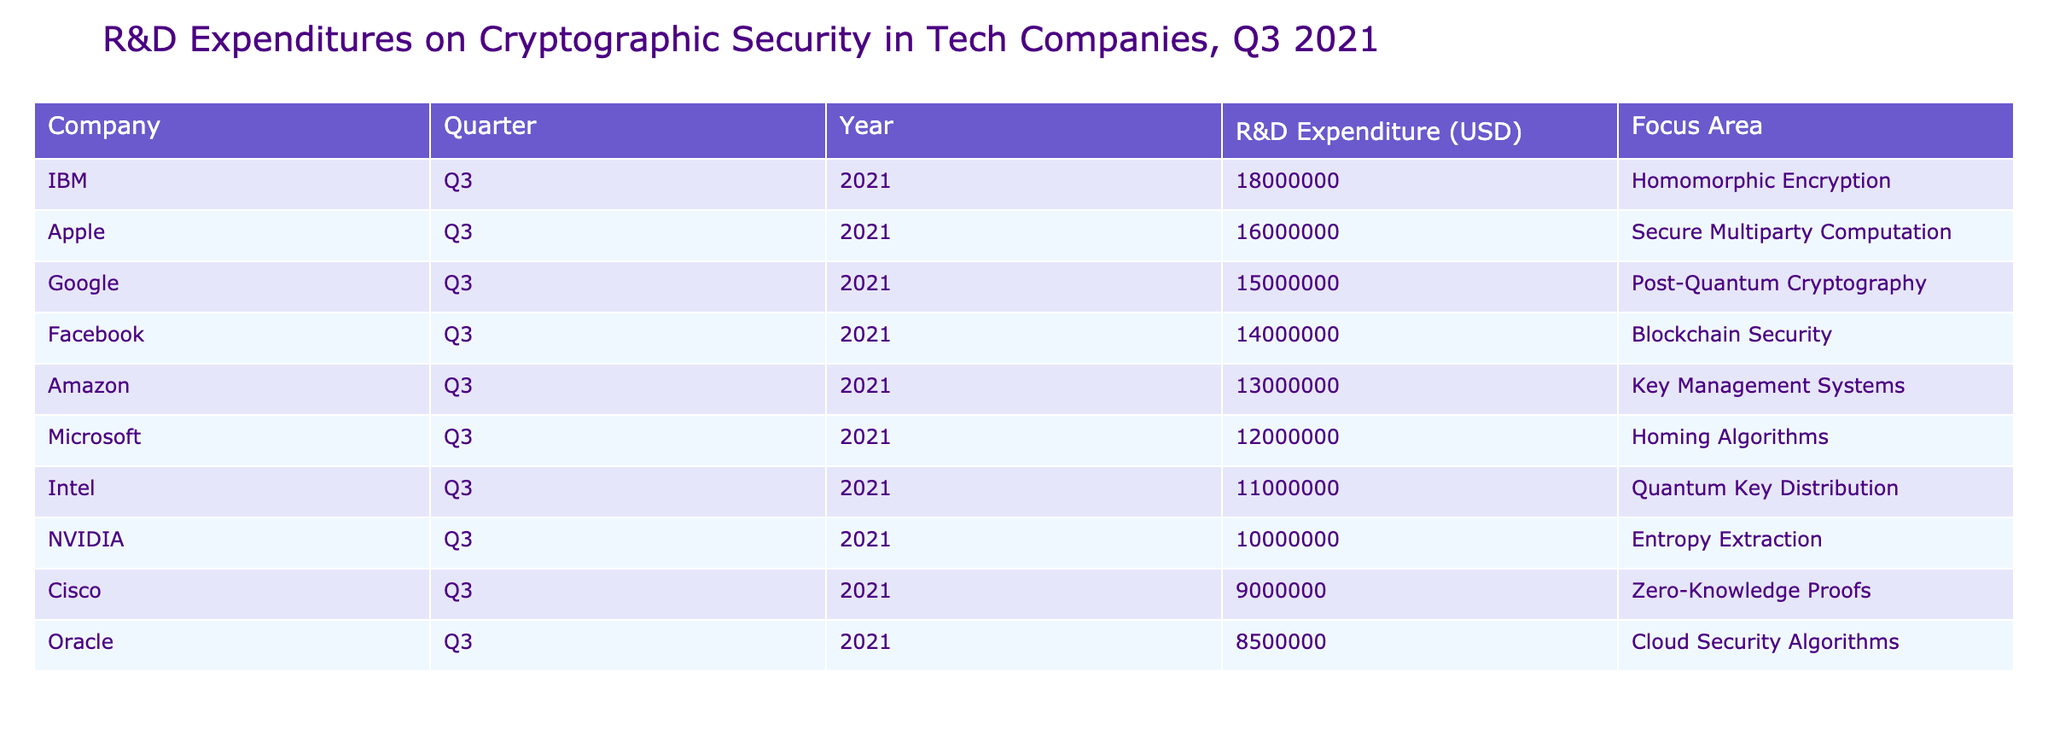What is the highest R&D expenditure recorded in the table? The highest R&D expenditure in the table is found by identifying the maximum value in the "R&D Expenditure (USD)" column. Reviewing the entries, IBM has the highest expenditure of 18000000 USD.
Answer: 18000000 Which company focused on Key Management Systems? By examining the "Focus Area" column, I can locate the entry for "Key Management Systems." The company listed under this focus area is Amazon.
Answer: Amazon What is the total R&D expenditure of the top three companies? To find the total R&D expenditure of the top three companies by expenditure, I add their individual expenditures: IBM (18000000), Apple (16000000), and Google (15000000). The total is 18000000 + 16000000 + 15000000 = 49000000 USD.
Answer: 49000000 Is Cisco's expenditure higher than NVIDIA's? Comparing the R&D expenditures for Cisco (9000000) and NVIDIA (10000000), I find that NVIDIA's is greater. Therefore, the statement is false.
Answer: No What is the average R&D expenditure across all companies listed? To calculate the average, I sum all R&D expenditures (15000000 + 12000000 + 18000000 + 16000000 + 14000000 + 13000000 + 11000000 + 10000000 + 9000000 + 8500000 = 12,885,000) and divide it by the number of companies (10). The total expenditure is 122500000 USD, resulting in an average of 122500000 / 10 = 12250000 USD.
Answer: 12250000 Which company has the lowest R&D expenditure and what is its focus area? The lowest R&D expenditure can be found by scanning the table for the minimum value in the "R&D Expenditure (USD)" column. Cisco has the lowest expenditure of 9000000 USD, focusing on Zero-Knowledge Proofs.
Answer: Cisco, Zero-Knowledge Proofs Do at least half of the companies focus on post-quantum cryptography? The only company focusing on post-quantum cryptography is Google. Since there are 10 companies in total, and only 1 focuses on post-quantum cryptography, it is evident that less than half do so.
Answer: No What is the difference in R&D expenditure between the company with the highest and the lowest expenditure? I first identify the highest expenditure (IBM: 18000000) and the lowest (Cisco: 9000000). To find the difference, I subtract the lowest from the highest: 18000000 - 9000000 = 9000000 USD.
Answer: 9000000 